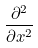Convert formula to latex. <formula><loc_0><loc_0><loc_500><loc_500>\frac { \partial ^ { 2 } } { \partial x ^ { 2 } }</formula> 